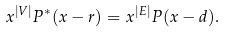<formula> <loc_0><loc_0><loc_500><loc_500>x ^ { | V | } P ^ { * } ( x - r ) = x ^ { | E | } P ( x - d ) .</formula> 